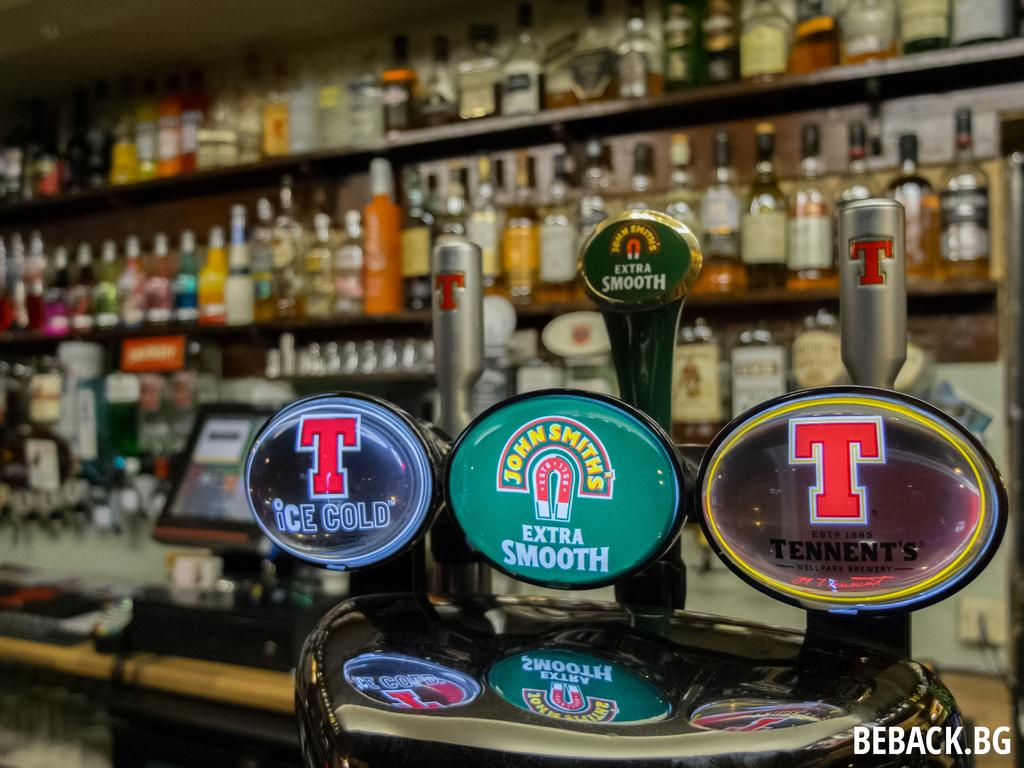<image>
Share a concise interpretation of the image provided. A bar offers many different brands of beer, such as John Smith's Extra Smooth and Tennent's. 